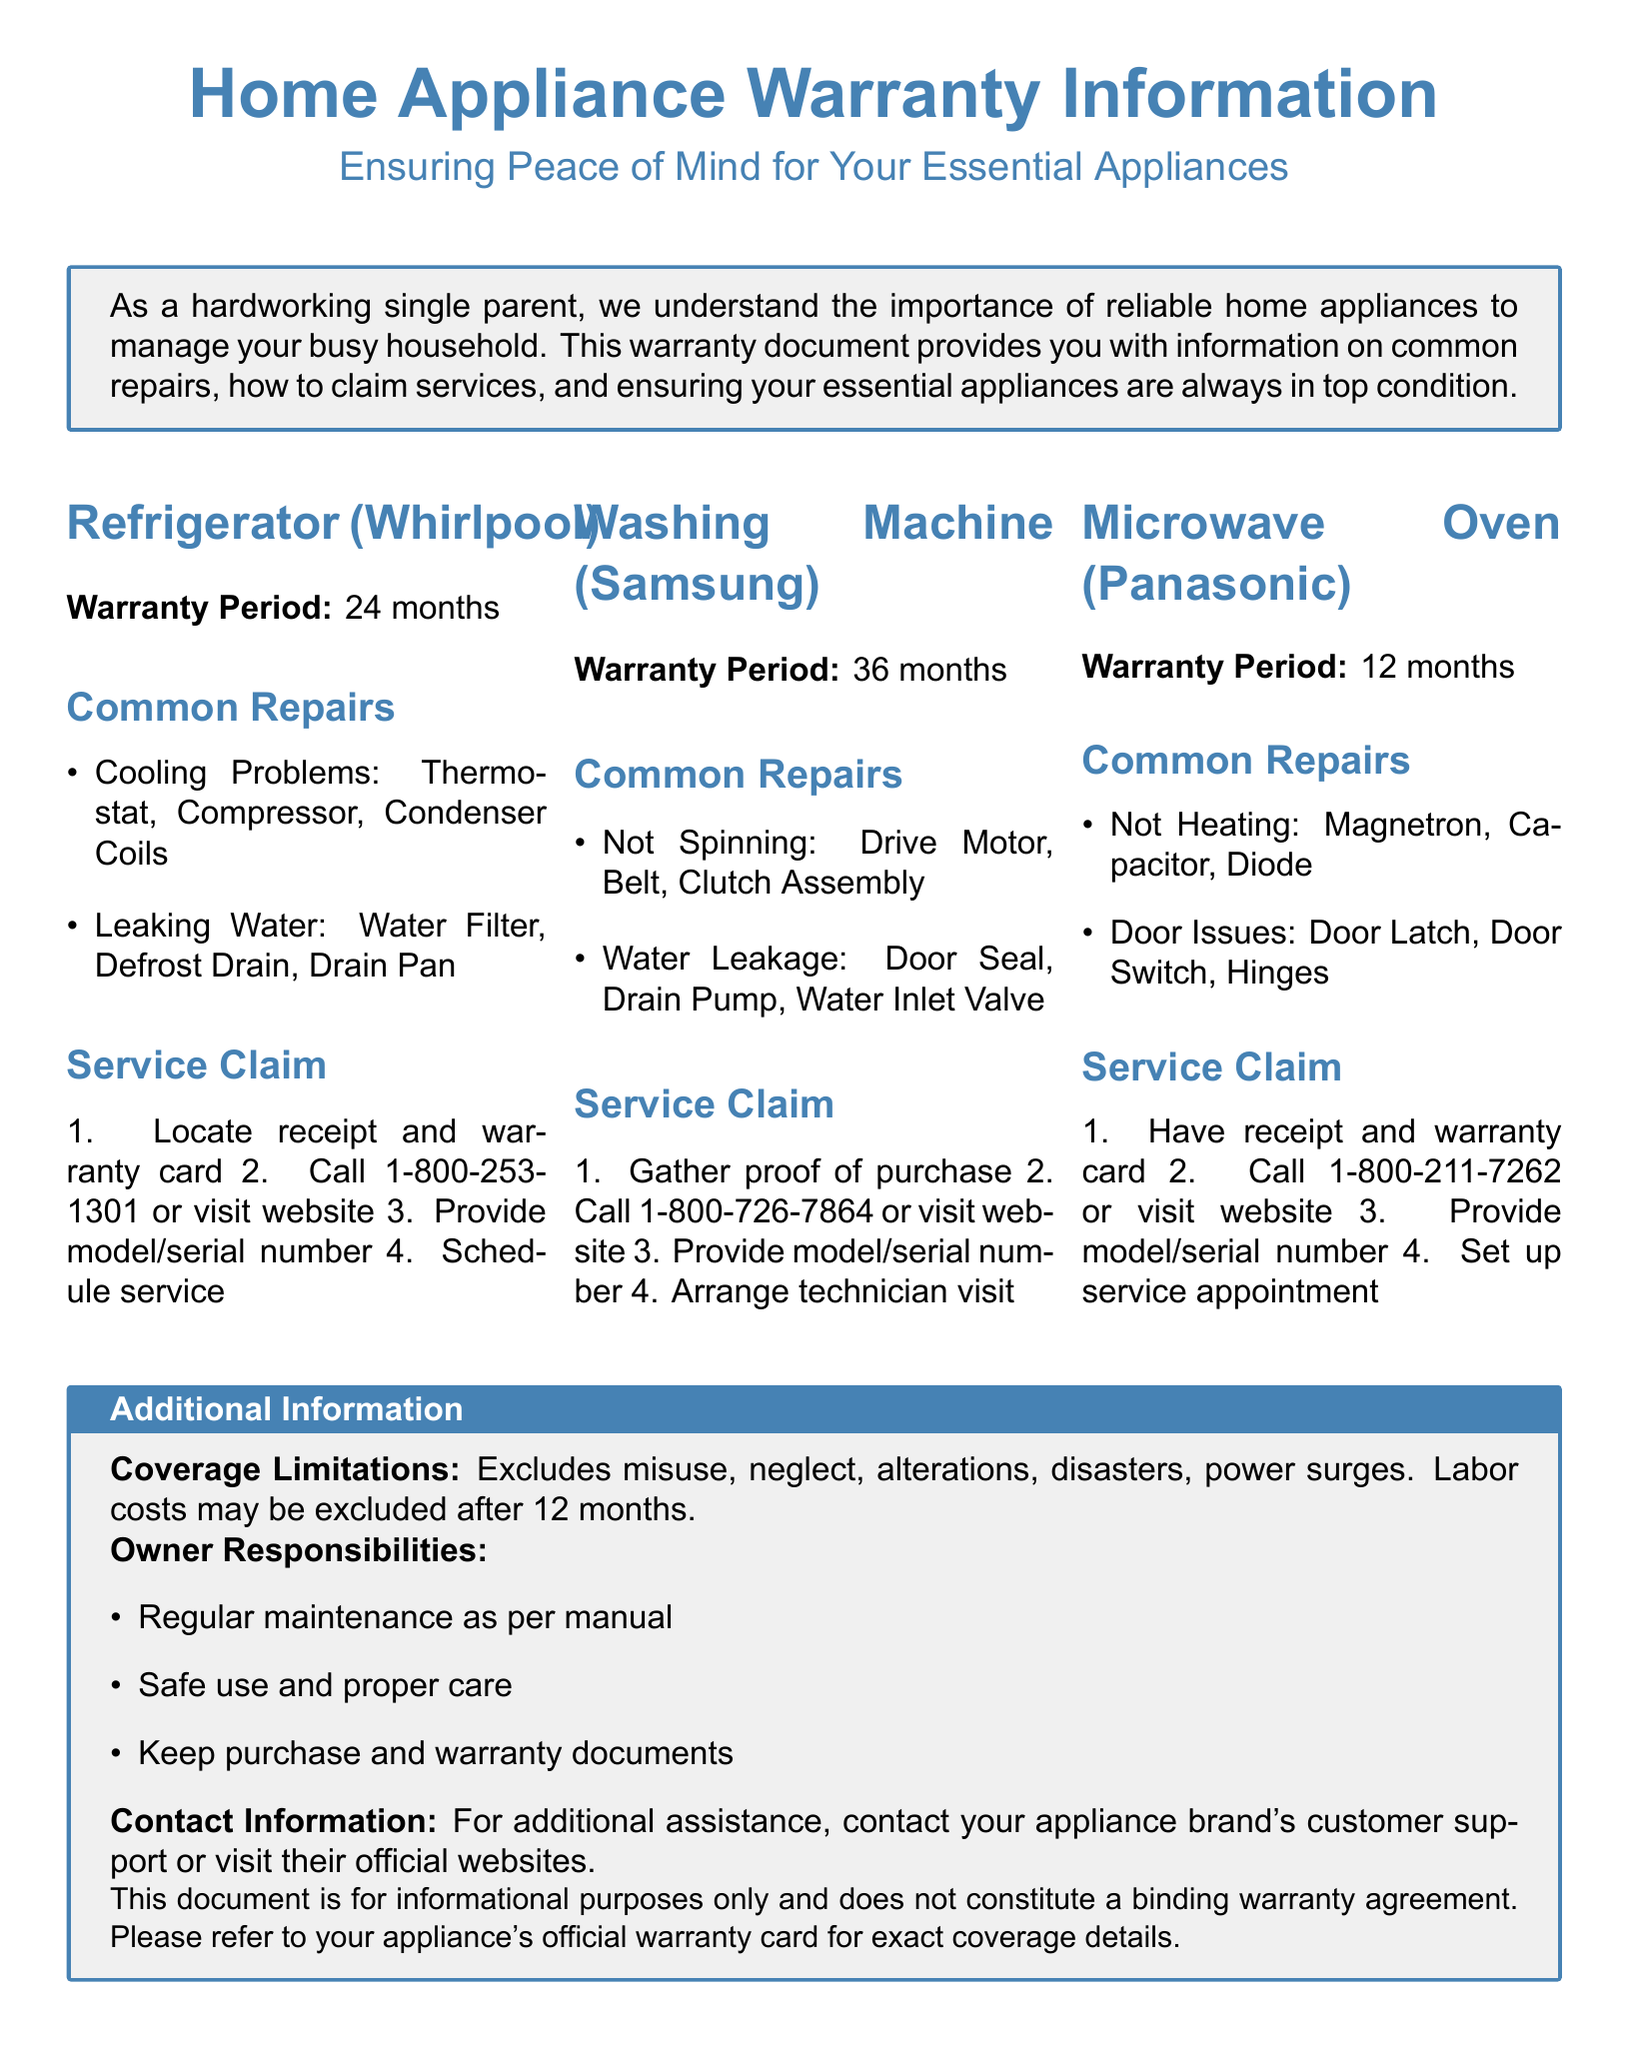What is the warranty period for the refrigerator? The document specifies that the warranty period for the refrigerator is 24 months.
Answer: 24 months What is a common repair for the washing machine? The document lists "Not Spinning" as a common repair for the washing machine, which may involve the Drive Motor, Belt, or Clutch Assembly.
Answer: Not Spinning How long is the warranty for the microwave oven? The text indicates the warranty period for the microwave oven is 12 months.
Answer: 12 months What should you gather to claim service for the washing machine? According to the document, you need to gather proof of purchase to claim service for the washing machine.
Answer: Proof of purchase What common issue occurs with leaking water in the refrigerator? The document mentions "Water Filter" as a common issue that can cause leaking water in the refrigerator.
Answer: Water Filter What is the contact number for the microwave service claim? The document provides the contact number 1-800-211-7262 for the microwave service claim.
Answer: 1-800-211-7262 What is excluded from warranty coverage? The document states that misuse, neglect, alterations, disasters, and power surges are excluded from warranty coverage.
Answer: Misuse What is one owner responsibility mentioned in the document? The document lists "Regular maintenance as per manual" as one of the owner responsibilities.
Answer: Regular maintenance What is the service claim process's first step for the refrigerator? The document specifies that the first step for claiming service for the refrigerator is locating the receipt and warranty card.
Answer: Locate receipt and warranty card 